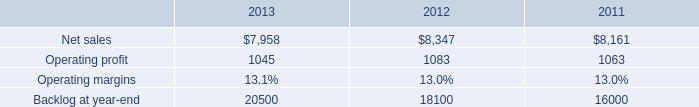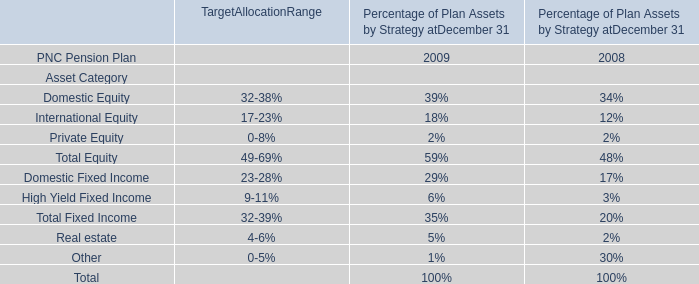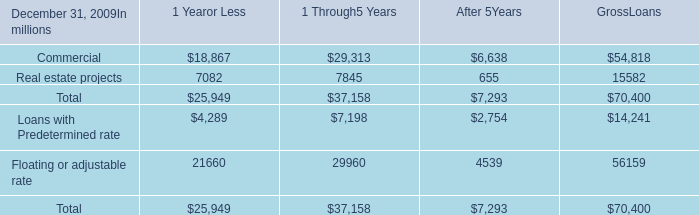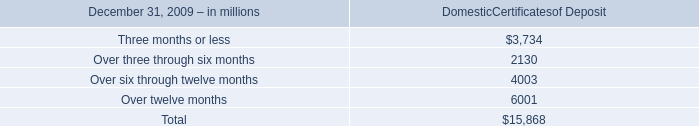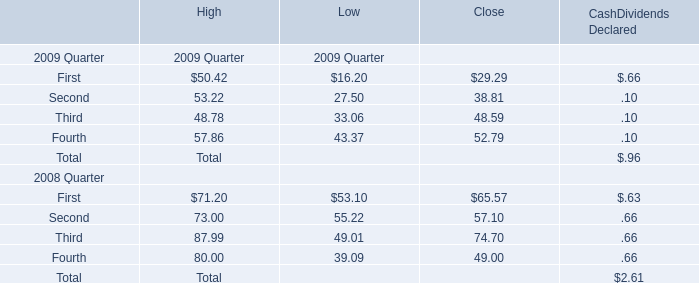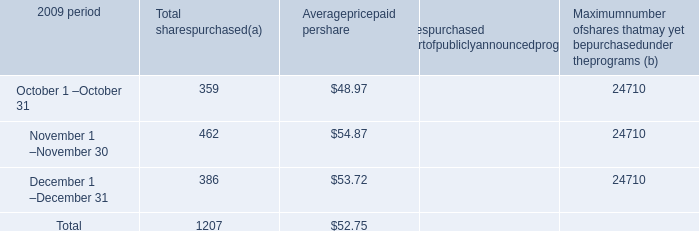What was the total amount of the Loans with Predetermined rate in the sections where Commercial greater than 20000？ (in million) 
Computations: (7198 + 14241)
Answer: 21439.0. 